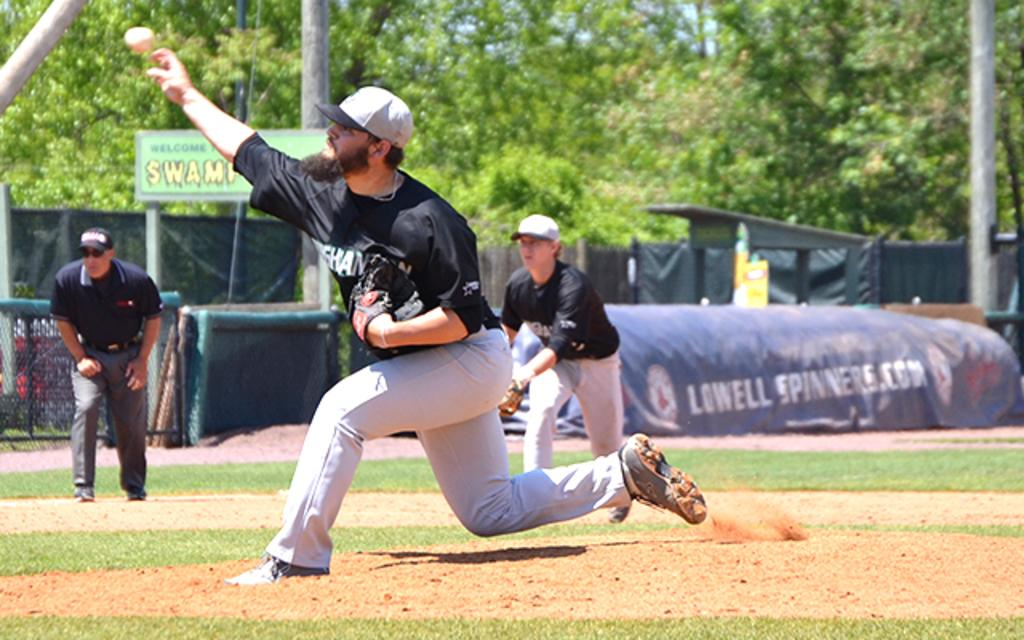<image>
Provide a brief description of the given image. The ad on the field covering is for Lowell Soinners.com 